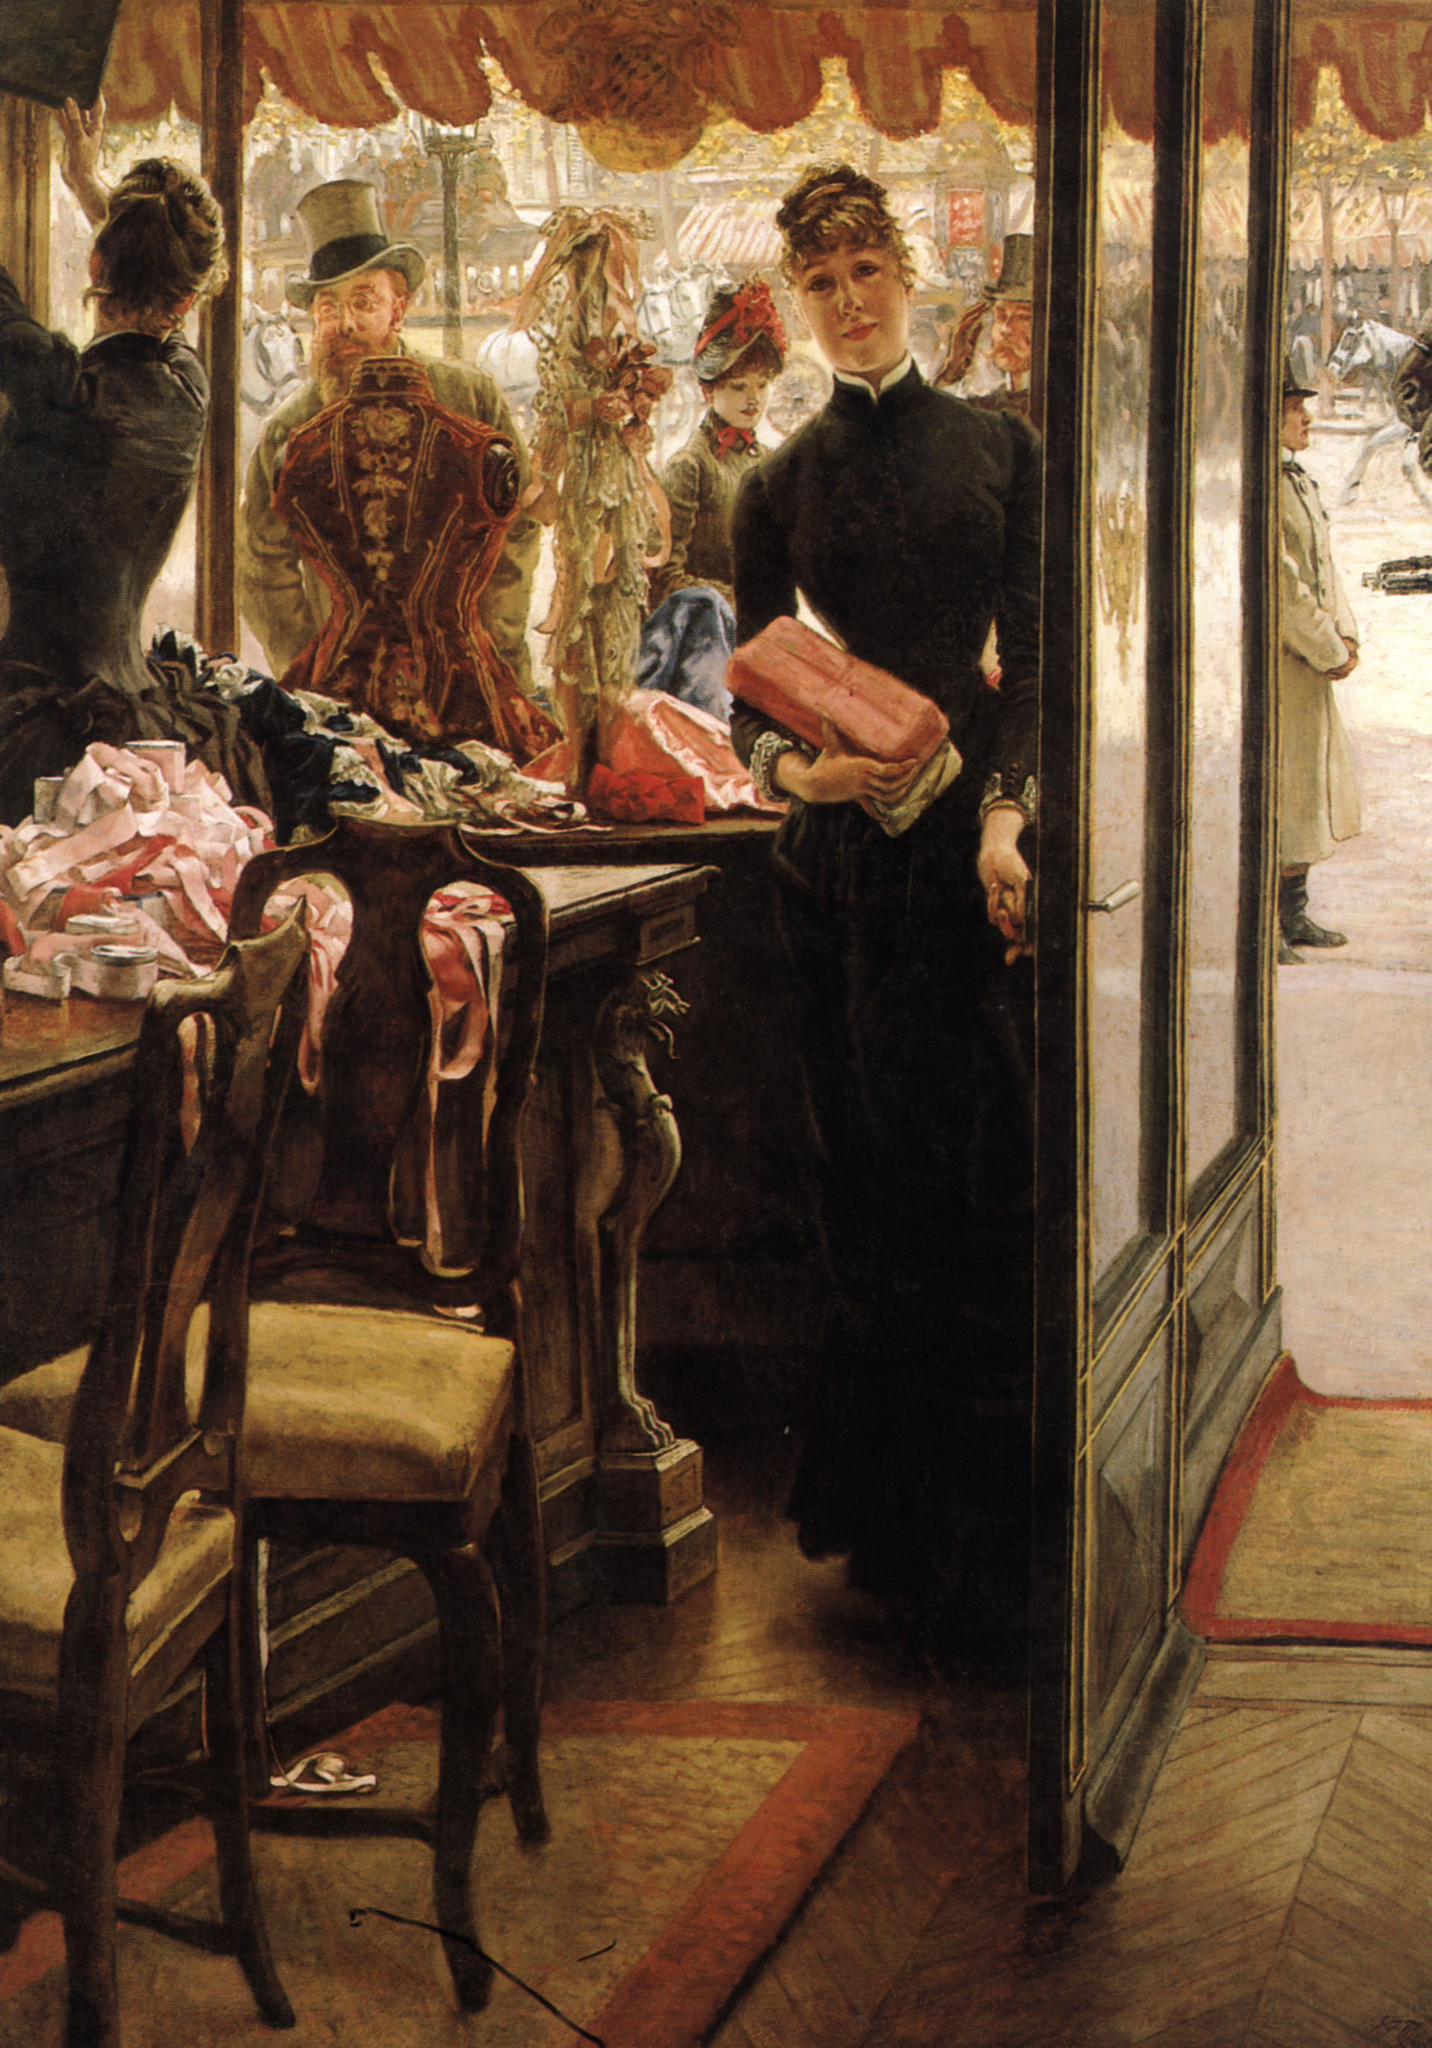What emotions does this painting evoke for the viewer? The painting evokes a mixture of emotions, drawing the viewer into its scene with a sense of nostalgia and reflection. The serene yet slightly distant expression of the shop girl elicits curiosity about her thoughts and feelings, possibly a sense of longing or daydreaming as she looks towards the active street outside. The warmth of the shop's interior juxtaposed with the cool day outside creates a comforting yet contrasting atmosphere. Overall, it may invoke feelings of introspection, curiosity, and a deeper appreciation for the intricacies of daily life in the past. Can you tell a story inspired by this painting? In the heart of Victorian London, Eliza worked at Madame Fleur's Boutique, a quaint shop known for its exquisite collections of hats, scarves, and dresses. Every morning, Eliza would carefully arrange the new arrivals, tying perfect bows and smoothing silk fabrics. Today, a pink scarf caught her attention. Its softness reminded her of the waltzes she used to dance at grand balls before misfortune struck her family, making her a shop girl. As she stood by the window, clutching the scarf, memories of the past mingled with the present scenery bustling with city life. Her gaze through the glass wasn’t just a look at the street but a bridge to memories, dreams, and unfulfilled promises. Little did she know, among the crowd stood a young artist, James, who would forever immortalize this moment in his canvas, capturing her silent grace and hidden stories for the world to see. 